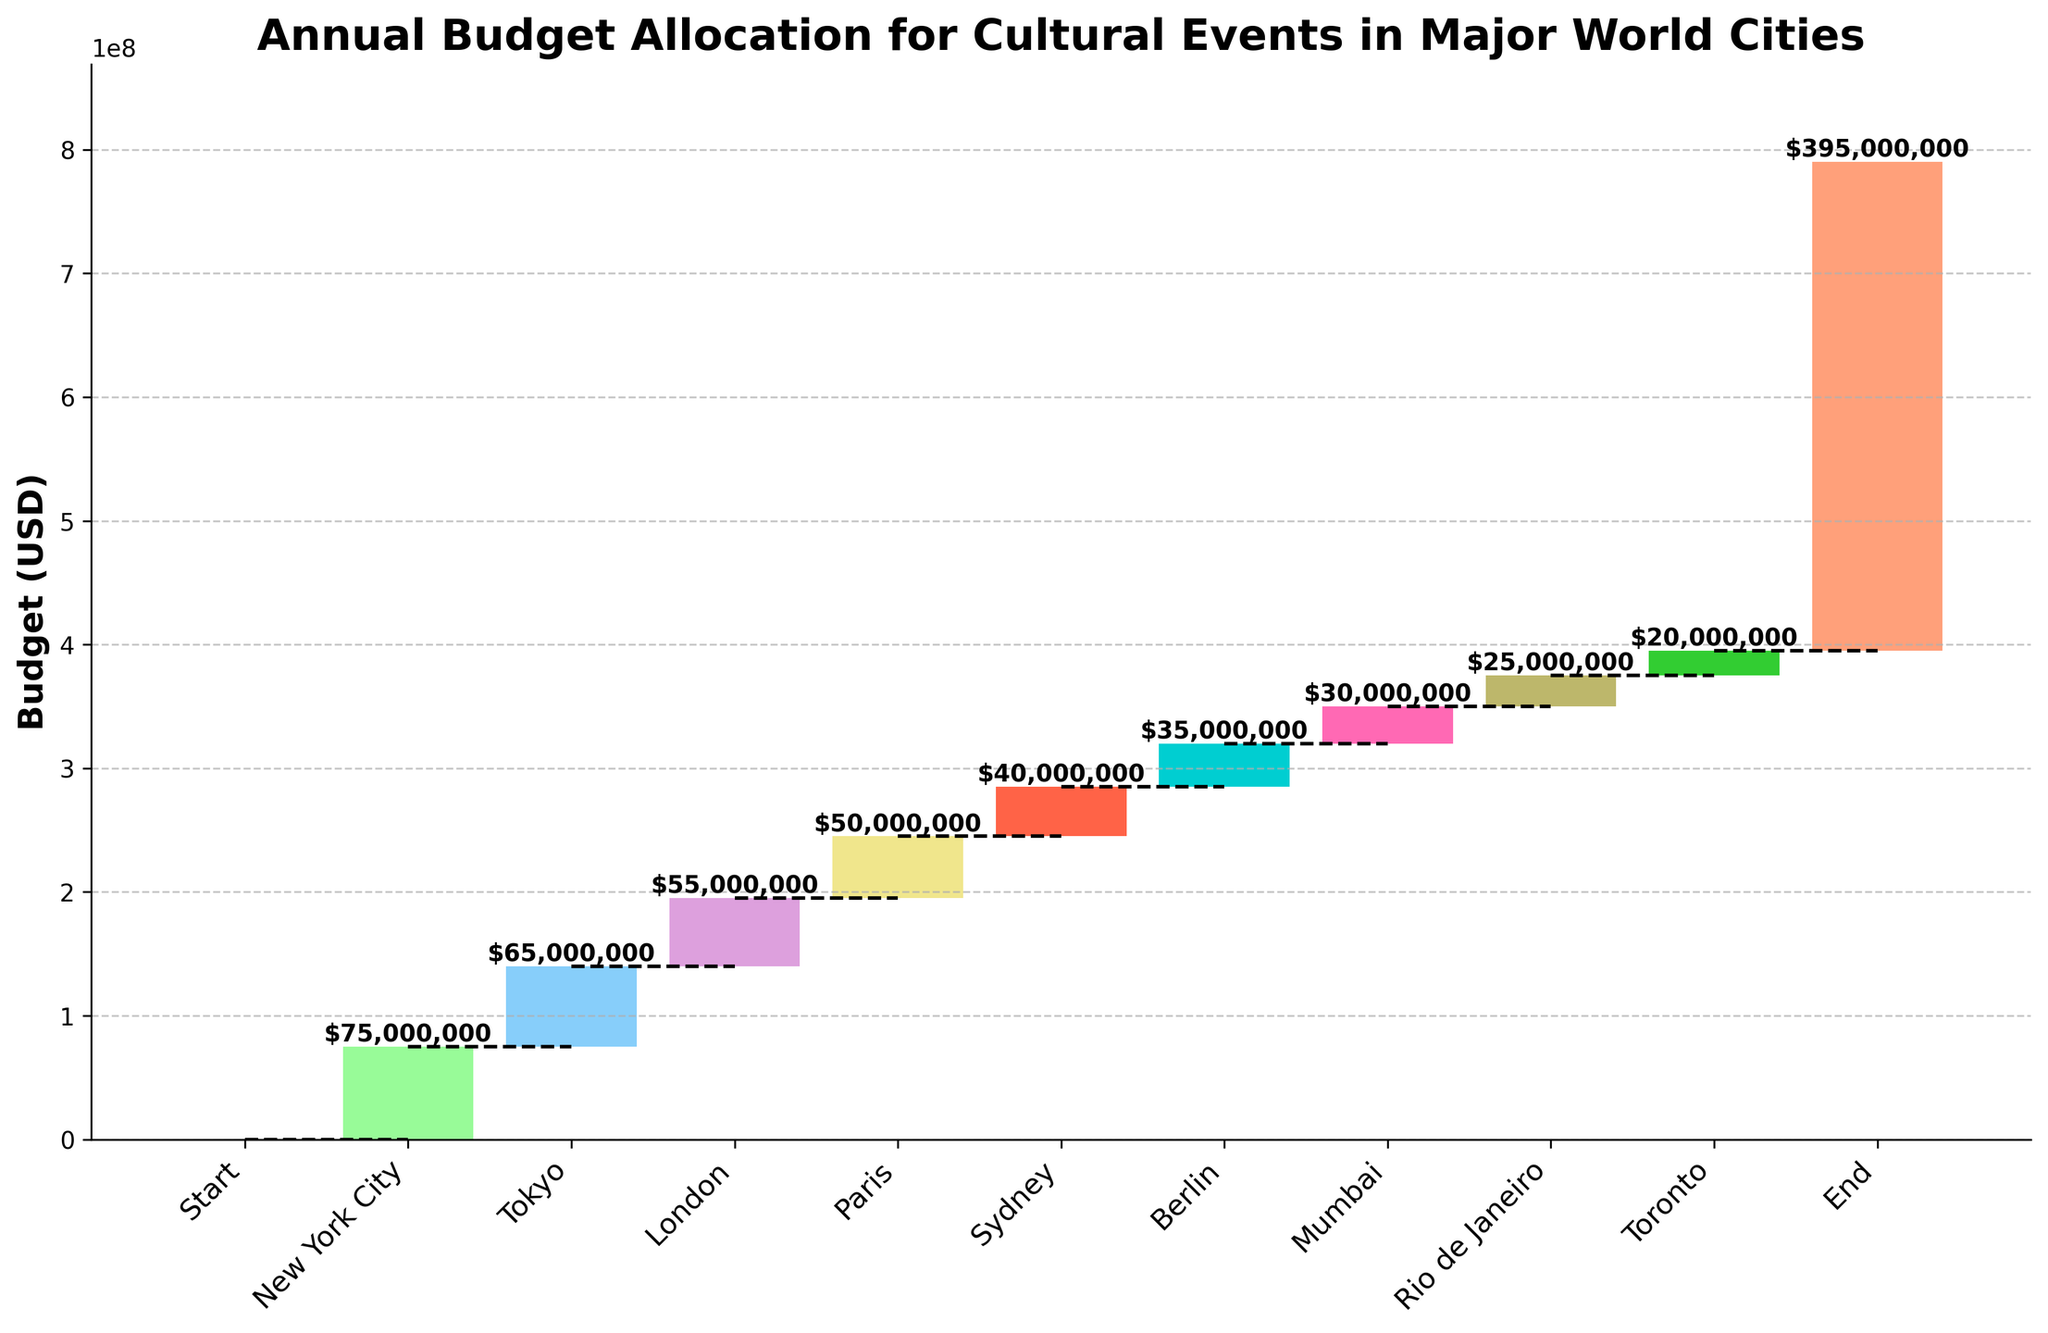What's the title of the figure? The title is usually displayed at the top of the figure to describe what the chart is about. Reading the chart's title helps in understanding its context.
Answer: Annual Budget Allocation for Cultural Events in Major World Cities How high is the total budget allocation at the end? The total budget allocation at the end is indicated by the cumulative sum of all the values displayed by the last bar in the chart.
Answer: 395,000,000 What is the budget allocation for New York City? Each city has a corresponding bar representing its budget allocation. Look at the bar labeled "New York City" and read its value.
Answer: 75,000,000 How does the budget allocation for Tokyo compare to that of Paris? Comparing the heights of the bars for Tokyo and Paris and their corresponding labels will show the budgets for both cities.
Answer: Tokyo's budget is higher than Paris's What's the sum of budget allocations for New York City and Tokyo? Add the values of the budget allocations for New York City and Tokyo: 75,000,000 and 65,000,000.
Answer: 140,000,000 Which city has the smallest budget allocation among the listed cities? The bar with the smallest height, apart from the 'Start' and 'End' bars, indicates the city with the lowest budget.
Answer: Toronto How much is the difference between the budget allocations for London and Mumbai? Subtract Mumbai's budget from London's budget: 55,000,000 - 30,000,000.
Answer: 25,000,000 What is visually unique about the 'End' category compared to the other categories? Unlike other categories, the 'End' category represents the cumulative total sum of all previous values. It is visually at the end and higher than any other bar.
Answer: It shows the total cumulative budget Which city comes immediately after Sydney on the chart? Looking at the sequence of bars, find the bar right after the one labeled "Sydney".
Answer: Berlin Are the budget allocations color-coded? Observing the bars, we can notice they are painted in different colors, which indicates that the chart employs color-coding for different cities.
Answer: Yes 